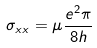<formula> <loc_0><loc_0><loc_500><loc_500>\sigma _ { x x } = \mu \frac { e ^ { 2 } \pi } { 8 h }</formula> 